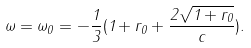Convert formula to latex. <formula><loc_0><loc_0><loc_500><loc_500>\omega = \omega _ { 0 } = - { \frac { 1 } { 3 } } ( 1 + r _ { 0 } + { \frac { 2 \sqrt { 1 + r _ { 0 } } } { c } } ) .</formula> 